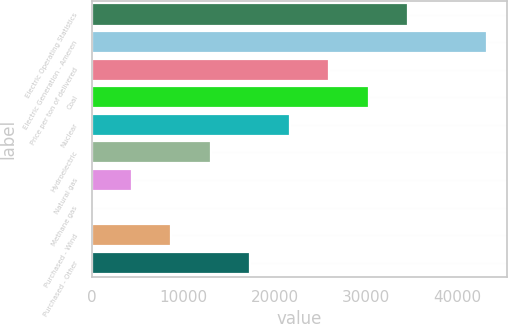Convert chart to OTSL. <chart><loc_0><loc_0><loc_500><loc_500><bar_chart><fcel>Electric Operating Statistics<fcel>Electric Generation - Ameren<fcel>Price per ton of delivered<fcel>Coal<fcel>Nuclear<fcel>Hydroelectric<fcel>Natural gas<fcel>Methane gas<fcel>Purchased - Wind<fcel>Purchased - Other<nl><fcel>34570.4<fcel>43213<fcel>25927.8<fcel>30249.1<fcel>21606.5<fcel>12964<fcel>4321.39<fcel>0.1<fcel>8642.68<fcel>17285.3<nl></chart> 